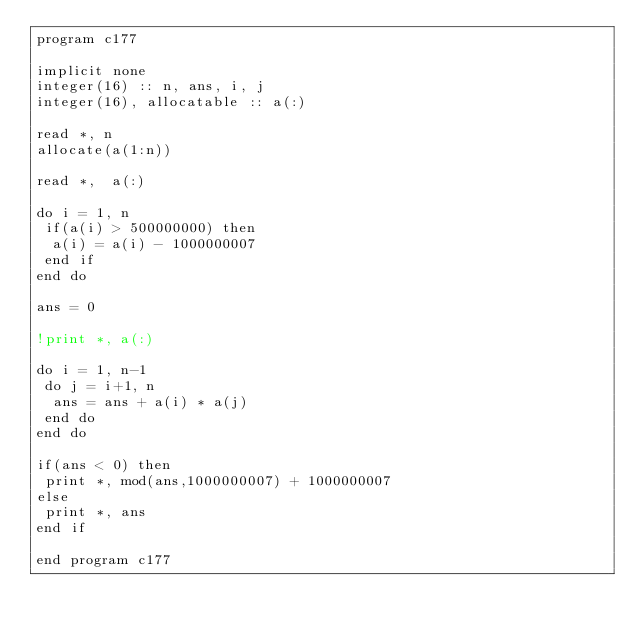<code> <loc_0><loc_0><loc_500><loc_500><_FORTRAN_>program c177

implicit none
integer(16) :: n, ans, i, j
integer(16), allocatable :: a(:)

read *, n
allocate(a(1:n))

read *,  a(:)

do i = 1, n
 if(a(i) > 500000000) then
  a(i) = a(i) - 1000000007
 end if
end do

ans = 0

!print *, a(:)

do i = 1, n-1
 do j = i+1, n
  ans = ans + a(i) * a(j)
 end do
end do

if(ans < 0) then
 print *, mod(ans,1000000007) + 1000000007
else
 print *, ans
end if

end program c177</code> 